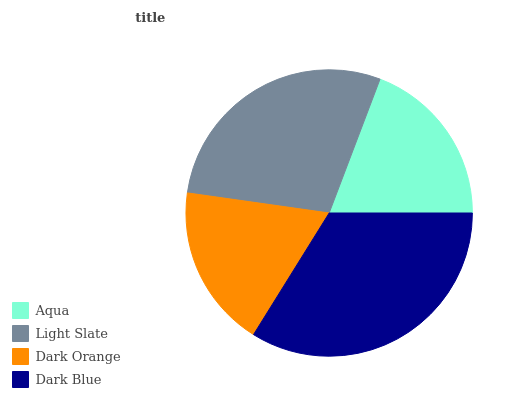Is Dark Orange the minimum?
Answer yes or no. Yes. Is Dark Blue the maximum?
Answer yes or no. Yes. Is Light Slate the minimum?
Answer yes or no. No. Is Light Slate the maximum?
Answer yes or no. No. Is Light Slate greater than Aqua?
Answer yes or no. Yes. Is Aqua less than Light Slate?
Answer yes or no. Yes. Is Aqua greater than Light Slate?
Answer yes or no. No. Is Light Slate less than Aqua?
Answer yes or no. No. Is Light Slate the high median?
Answer yes or no. Yes. Is Aqua the low median?
Answer yes or no. Yes. Is Aqua the high median?
Answer yes or no. No. Is Dark Orange the low median?
Answer yes or no. No. 